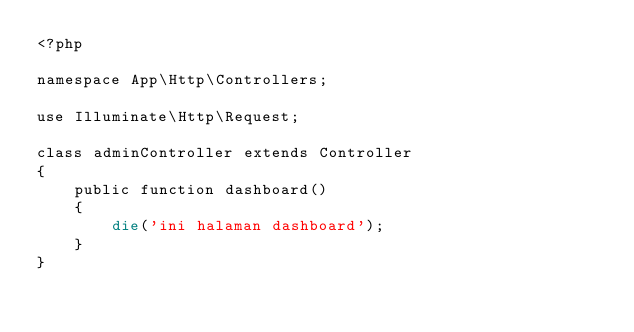Convert code to text. <code><loc_0><loc_0><loc_500><loc_500><_PHP_><?php

namespace App\Http\Controllers;

use Illuminate\Http\Request;

class adminController extends Controller
{
    public function dashboard()
	{
		die('ini halaman dashboard');
	}
}
</code> 